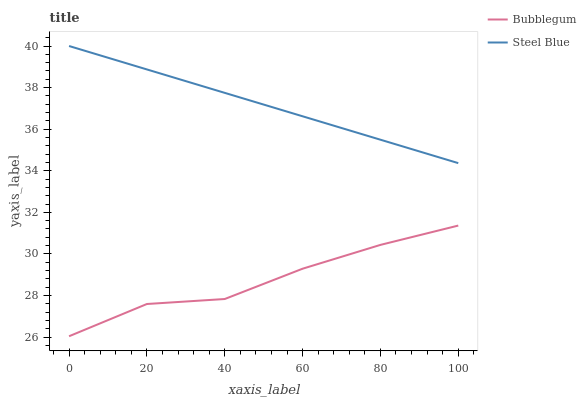Does Bubblegum have the minimum area under the curve?
Answer yes or no. Yes. Does Steel Blue have the maximum area under the curve?
Answer yes or no. Yes. Does Bubblegum have the maximum area under the curve?
Answer yes or no. No. Is Steel Blue the smoothest?
Answer yes or no. Yes. Is Bubblegum the roughest?
Answer yes or no. Yes. Is Bubblegum the smoothest?
Answer yes or no. No. Does Bubblegum have the lowest value?
Answer yes or no. Yes. Does Steel Blue have the highest value?
Answer yes or no. Yes. Does Bubblegum have the highest value?
Answer yes or no. No. Is Bubblegum less than Steel Blue?
Answer yes or no. Yes. Is Steel Blue greater than Bubblegum?
Answer yes or no. Yes. Does Bubblegum intersect Steel Blue?
Answer yes or no. No. 